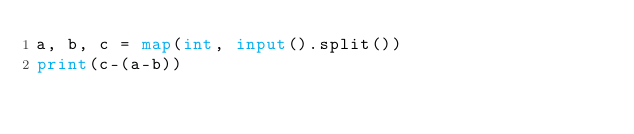Convert code to text. <code><loc_0><loc_0><loc_500><loc_500><_Python_>a, b, c = map(int, input().split())
print(c-(a-b))</code> 